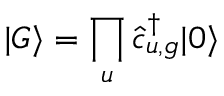<formula> <loc_0><loc_0><loc_500><loc_500>| G \rangle = \prod _ { u } \hat { c } _ { u , g } ^ { \dagger } | 0 \rangle</formula> 